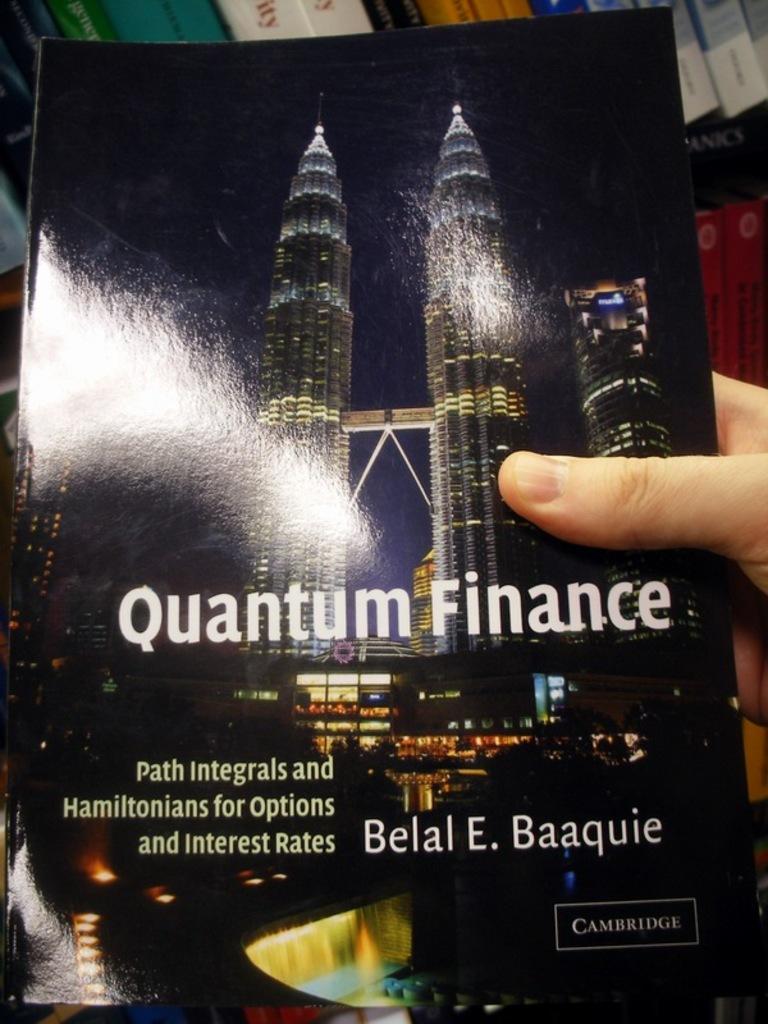Who wrote this book?
Offer a very short reply. Belal e. baaquie. 